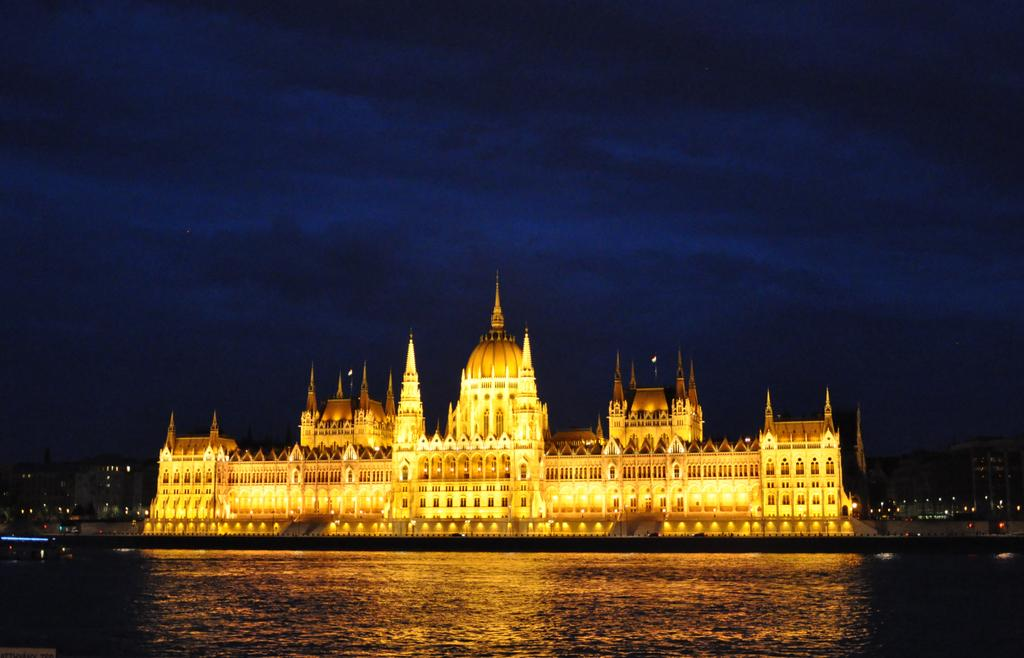What type of structure is visible in the image? There is a building in the image. Can you describe the lighting conditions in the image? There is light in the image. What is present at the bottom of the image? There is water at the bottom of the image. What can be seen in the sky at the top of the image? There are clouds in the sky at the top of the image. What type of brick is used to construct the building in the family in the image? There is no mention of a building family in the image, and the building's construction materials are not specified. 